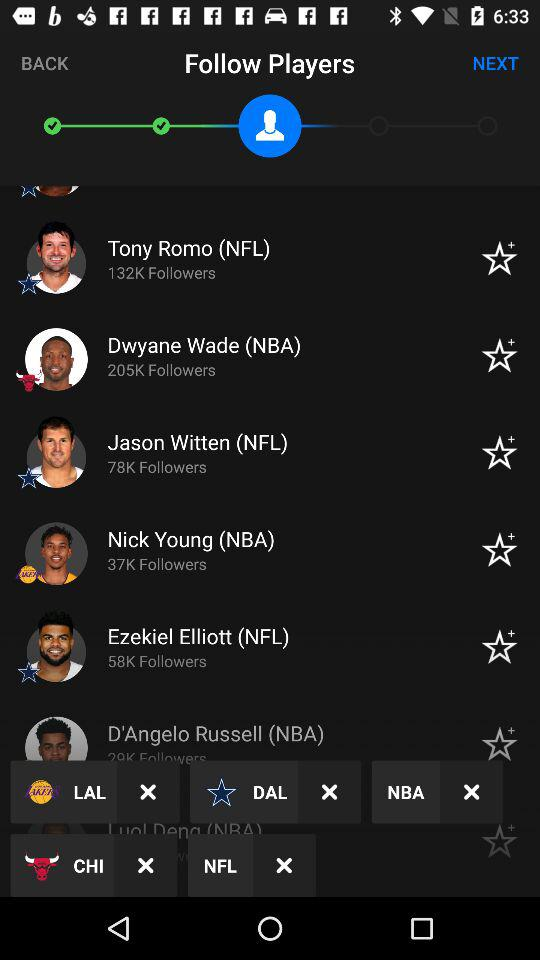How many followers does Dwyane Wade have? Dwyane Wade has 205K followers. 